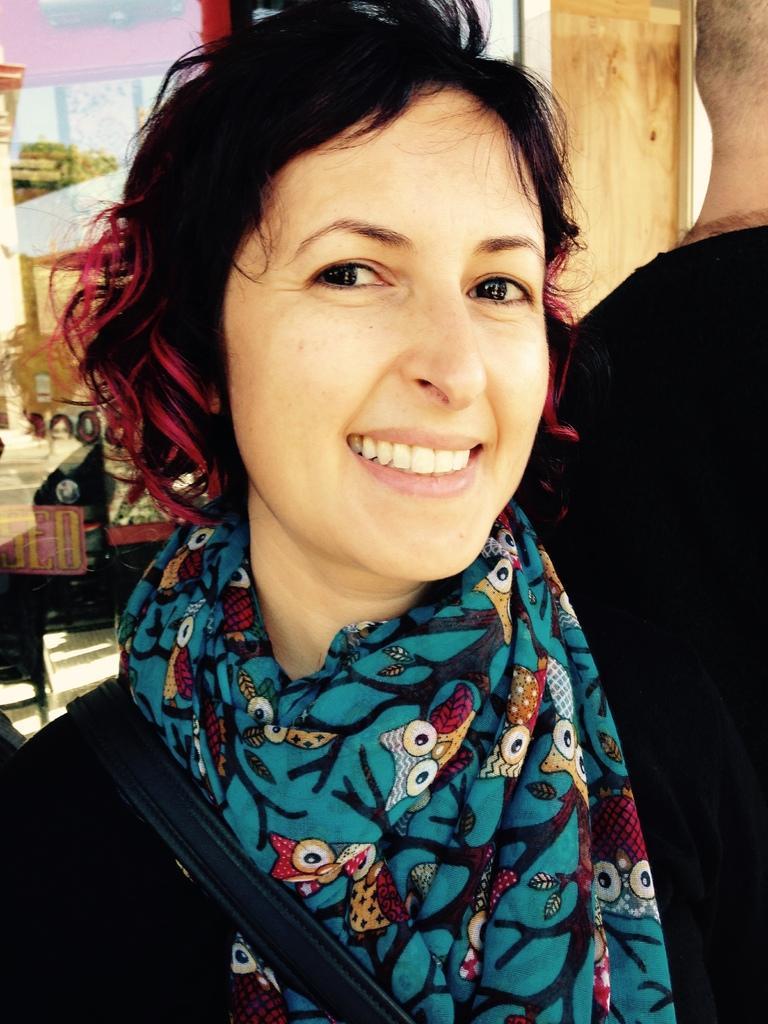In one or two sentences, can you explain what this image depicts? In this image we can see a woman is standing, she is smiling, here is the scarf, she is wearing the black dress. 